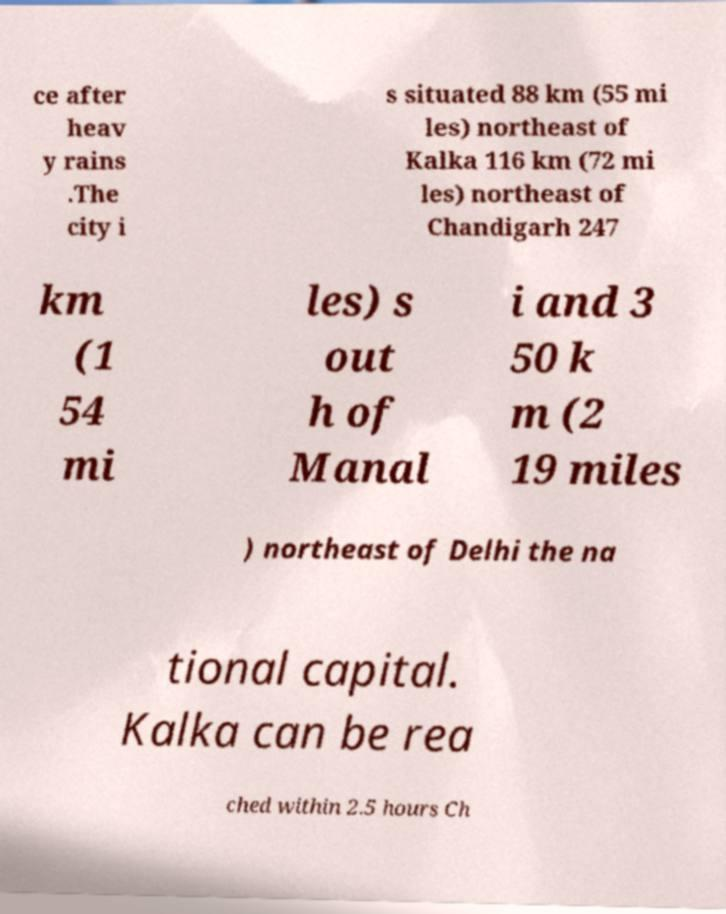I need the written content from this picture converted into text. Can you do that? ce after heav y rains .The city i s situated 88 km (55 mi les) northeast of Kalka 116 km (72 mi les) northeast of Chandigarh 247 km (1 54 mi les) s out h of Manal i and 3 50 k m (2 19 miles ) northeast of Delhi the na tional capital. Kalka can be rea ched within 2.5 hours Ch 